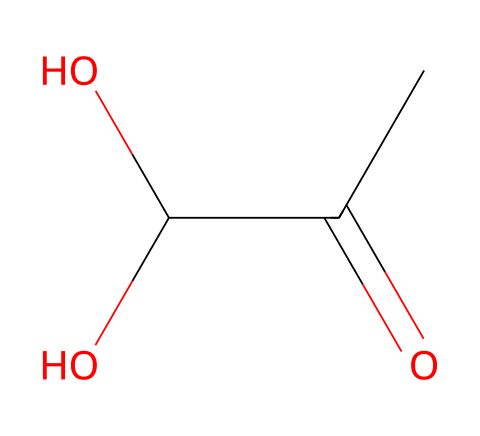What is the molecular formula of lactic acid? The SMILES representation provides enough information to deduce that lactic acid consists of three carbon atoms (C), six hydrogen atoms (H), and three oxygen atoms (O), leading to the molecular formula C3H6O3.
Answer: C3H6O3 How many carbon atoms are in lactic acid? By analyzing the SMILES representation, we can count that there are three ‘C’ atoms present, indicating the number of carbon atoms in the molecular structure of lactic acid.
Answer: 3 What type of functional groups are present in lactic acid? Looking at the structure, we see a hydroxyl group (-OH) and a carboxylic acid group (-COOH). These define the functional groups present in lactic acid.
Answer: hydroxyl and carboxylic acid Does lactic acid have a hydroxyl group? The presence of the -OH group in the SMILES representation indicates that there is a hydroxyl group, confirming lactic acid indeed contains this functional group.
Answer: yes What role does lactic acid play in muscle fatigue? Lactic acid builds up in muscles during strenuous exercise and is associated with the sensation of fatigue due to its accumulation and the subsequent drop in pH. This is derived from the understanding of its physiological roles during anaerobic metabolism.
Answer: muscle fatigue How does lactic acid affect pH levels in muscles? The accumulation of lactic acid leads to an increase in hydrogen ions (H+) in the muscle, which decreases pH levels, thus creating a more acidic environment responsible for discomfort and fatigue.
Answer: decrease pH levels Can lactic acid be converted back to glucose? Yes, lactic acid can be transported to the liver where it can be converted back to glucose through gluconeogenesis, which is essential for energy replenishment during recovery.
Answer: yes 